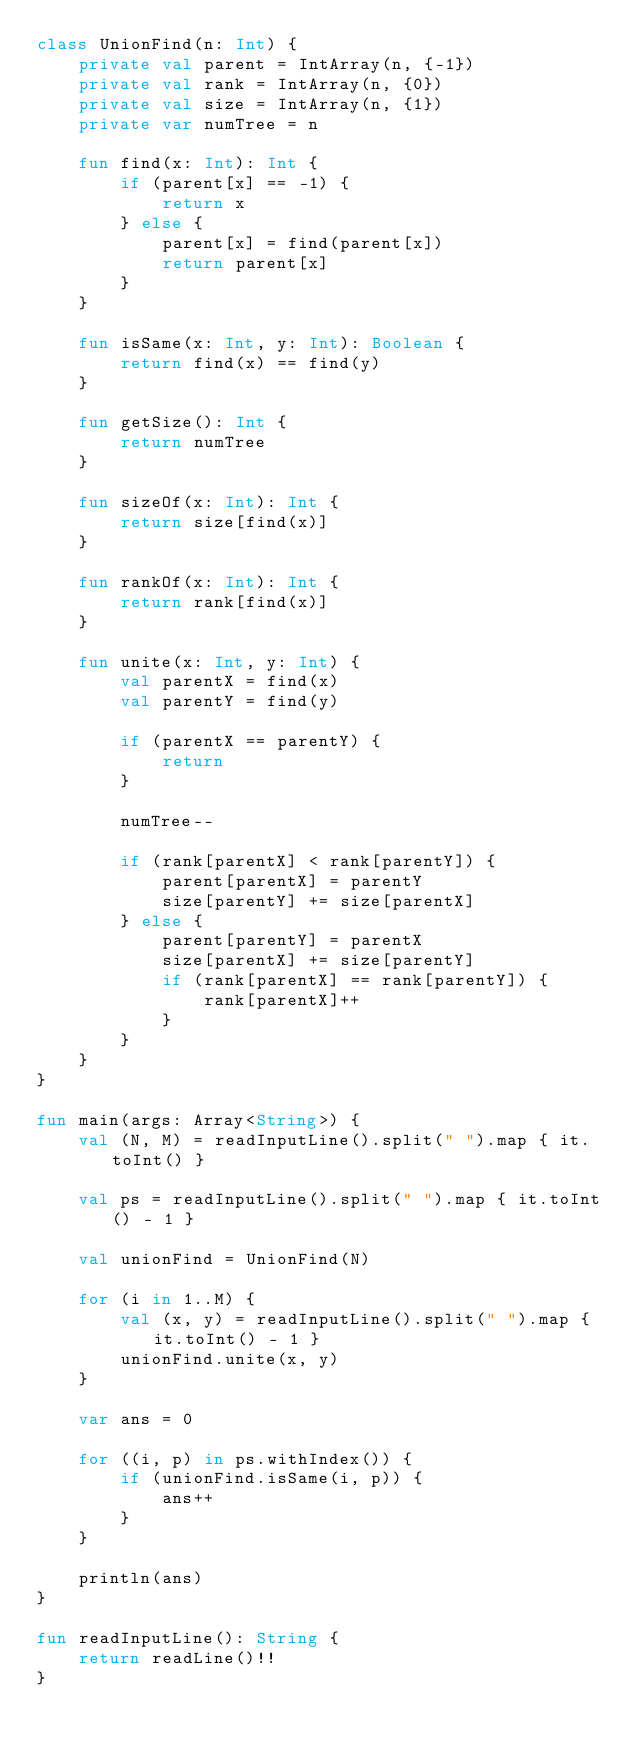Convert code to text. <code><loc_0><loc_0><loc_500><loc_500><_Kotlin_>class UnionFind(n: Int) {
    private val parent = IntArray(n, {-1})
    private val rank = IntArray(n, {0})
    private val size = IntArray(n, {1})
    private var numTree = n
    
    fun find(x: Int): Int {
        if (parent[x] == -1) {
            return x
        } else {
            parent[x] = find(parent[x])
            return parent[x]
        }
    }
    
    fun isSame(x: Int, y: Int): Boolean {
        return find(x) == find(y)
    }
    
    fun getSize(): Int {
        return numTree
    }
    
    fun sizeOf(x: Int): Int {
        return size[find(x)]
    }
    
    fun rankOf(x: Int): Int {
        return rank[find(x)]
    }
    
    fun unite(x: Int, y: Int) {
        val parentX = find(x)
        val parentY = find(y)
        
        if (parentX == parentY) {
            return
        }
        
        numTree--
        
        if (rank[parentX] < rank[parentY]) {
            parent[parentX] = parentY
            size[parentY] += size[parentX]
        } else {
            parent[parentY] = parentX
            size[parentX] += size[parentY]
            if (rank[parentX] == rank[parentY]) {
                rank[parentX]++
            }
        }
    }
}

fun main(args: Array<String>) {
    val (N, M) = readInputLine().split(" ").map { it.toInt() }
    
    val ps = readInputLine().split(" ").map { it.toInt() - 1 }
    
    val unionFind = UnionFind(N)
    
    for (i in 1..M) {
        val (x, y) = readInputLine().split(" ").map { it.toInt() - 1 }
        unionFind.unite(x, y)
    }
    
    var ans = 0
    
    for ((i, p) in ps.withIndex()) {
        if (unionFind.isSame(i, p)) {
            ans++
        }
    }

    println(ans)
}

fun readInputLine(): String {
    return readLine()!!
}
</code> 